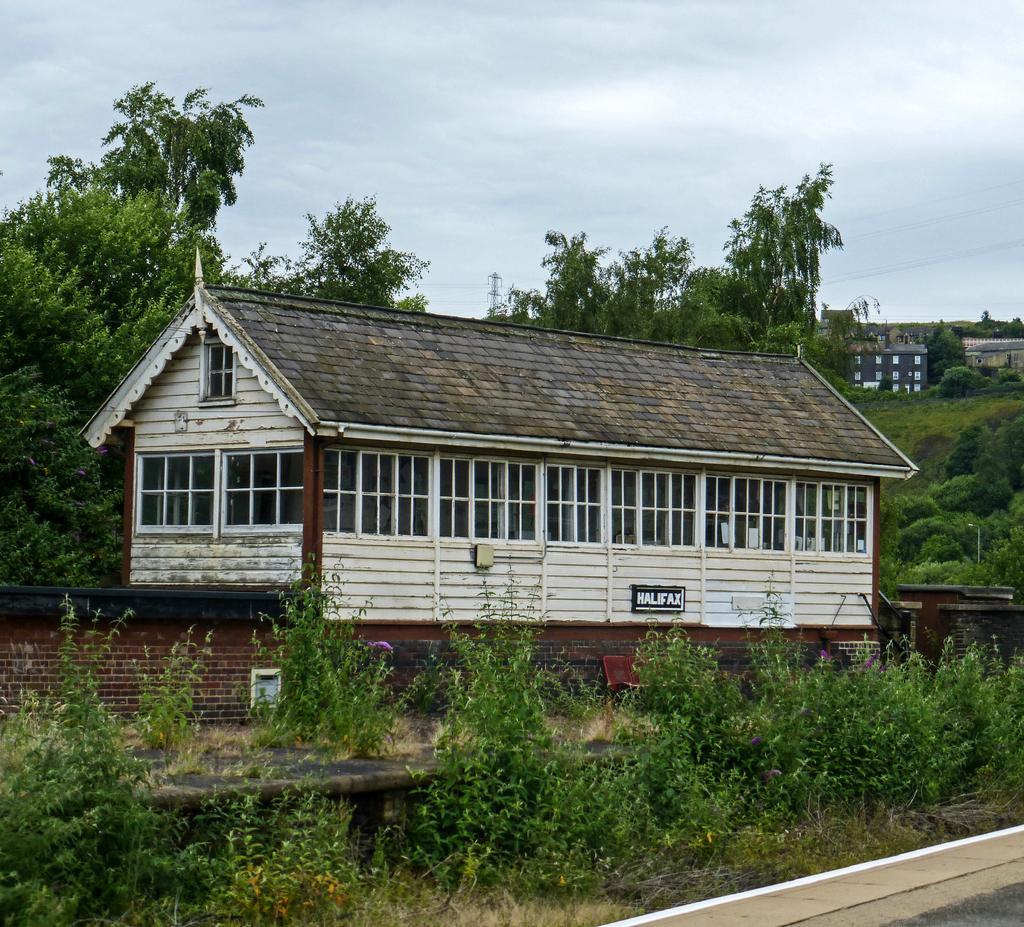How would you summarize this image in a sentence or two? In this picture we can see a few plants, a brick wall, houses, trees, wires and other objects. We can see the sky. 